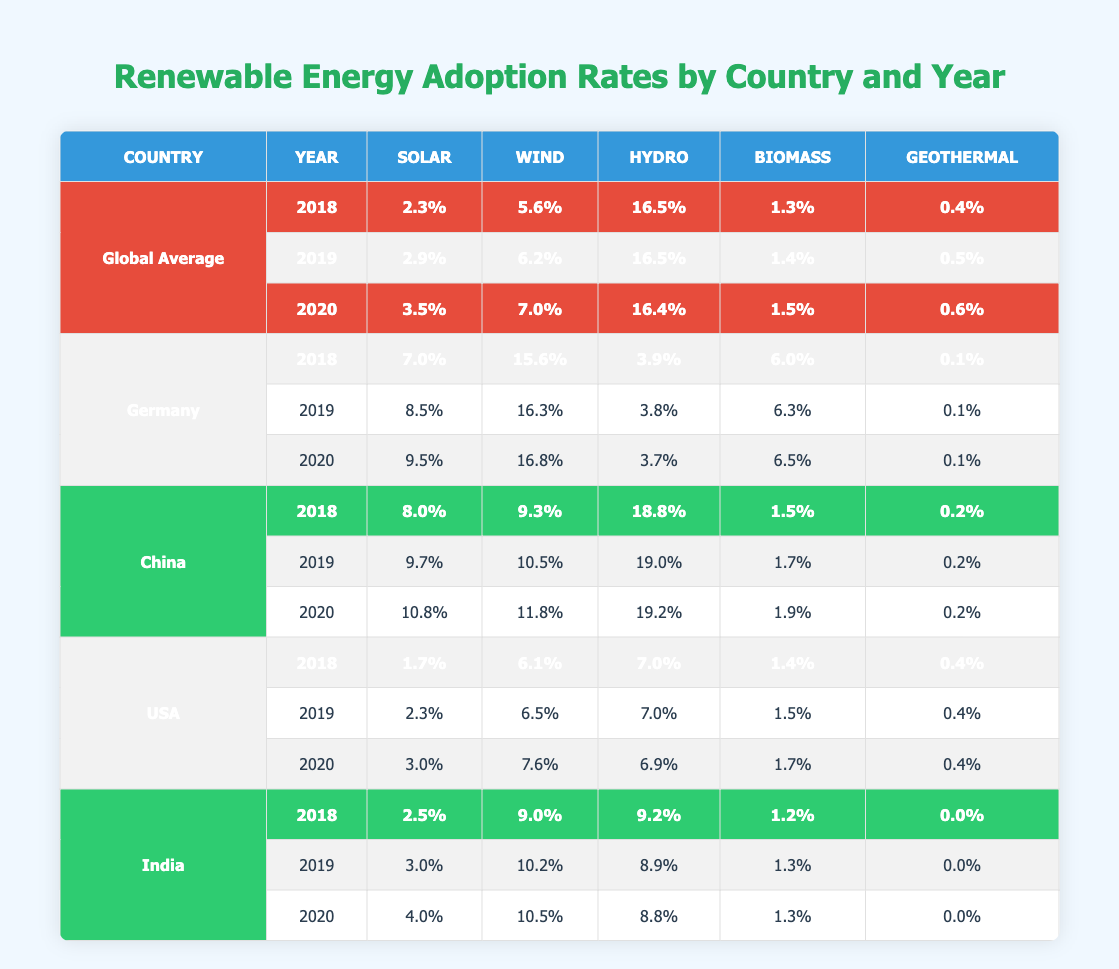What was the solar energy adoption rate in Germany in 2019? In the table under Germany for the year 2019, the solar energy adoption rate is specifically listed. It states that solar energy reached 8.5% in that year.
Answer: 8.5% Which country had the highest wind energy adoption rate in 2020? In the table, I need to look at the wind energy percentages for each country in 2020. Germany had 16.8%, China had 11.8%, the USA had 7.6%, and India had 10.5%. Therefore, Germany had the highest at 16.8%.
Answer: Germany What is the average hydro energy adoption rate for the USA between 2018 and 2020? To find the average hydro energy adoption rate for the USA, I note the rates: in 2018 it was 7.0%, in 2019 it was 7.0%, and in 2020 it was 6.9%. Calculating the average: (7.0 + 7.0 + 6.9) / 3 = 6.9667, which rounds to 7.0% when written to one decimal place.
Answer: 7.0% Did China have a higher biomass energy adoption rate than the global average in 2019? Checking the biomass rates: China had 1.7% in 2019 while the global average was 1.4%. Since 1.7% is greater than 1.4%, the answer is yes.
Answer: Yes What was the total percentage of renewable energy (solar, wind, hydro, biomass, geothermal) for India in 2020? I first find India's adoption rates for 2020: Solar (4.0%), Wind (10.5%), Hydro (8.8%), Biomass (1.3%), and Geothermal (0.0%). Then I sum these figures: 4.0 + 10.5 + 8.8 + 1.3 + 0.0 = 24.6%. Therefore, the total percentage of renewable energy for India is 24.6%.
Answer: 24.6% How much did the solar energy adoption rate increase in Germany from 2018 to 2020? I look at the solar energy rates: in 2018, it was 7.0% and in 2020 it rose to 9.5%. The increase is calculated as 9.5 - 7.0 = 2.5%. Therefore, Germany's solar energy adoption rate increased by 2.5%.
Answer: 2.5% Which country had the lowest geothermal energy adoption rate in 2018? In 2018, the geothermal energy rates were as follows: Germany (0.1%), China (0.2%), USA (0.4%), and India (0.0%). The lowest rate is found in India at 0.0%.
Answer: India Is the wind energy adoption rate higher in any year for China than the global average? I compare the wind energy rates: China's rates are 9.3% (2018), 10.5% (2019), and 11.8% (2020) while the global averages are 5.6% (2018), 6.2% (2019), and 7.0% (2020). All years show that China's rates exceed the global average, confirming a yes answer.
Answer: Yes 